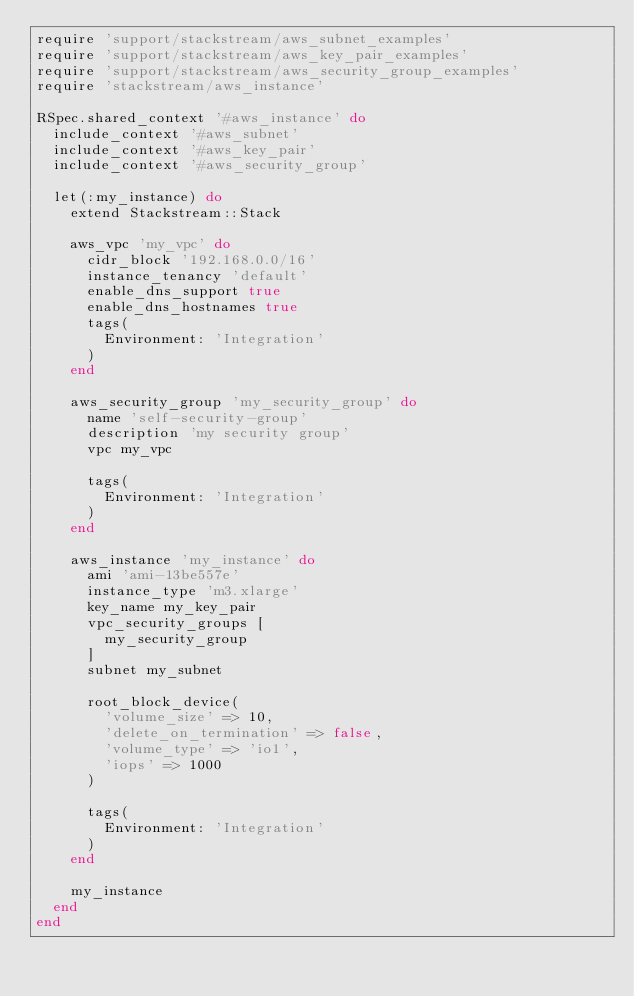Convert code to text. <code><loc_0><loc_0><loc_500><loc_500><_Ruby_>require 'support/stackstream/aws_subnet_examples'
require 'support/stackstream/aws_key_pair_examples'
require 'support/stackstream/aws_security_group_examples'
require 'stackstream/aws_instance'

RSpec.shared_context '#aws_instance' do
  include_context '#aws_subnet'
  include_context '#aws_key_pair'
  include_context '#aws_security_group'

  let(:my_instance) do
    extend Stackstream::Stack

    aws_vpc 'my_vpc' do
      cidr_block '192.168.0.0/16'
      instance_tenancy 'default'
      enable_dns_support true
      enable_dns_hostnames true
      tags(
        Environment: 'Integration'
      )
    end

    aws_security_group 'my_security_group' do
      name 'self-security-group'
      description 'my security group'
      vpc my_vpc

      tags(
        Environment: 'Integration'
      )
    end

    aws_instance 'my_instance' do
      ami 'ami-13be557e'
      instance_type 'm3.xlarge'
      key_name my_key_pair
      vpc_security_groups [
        my_security_group
      ]
      subnet my_subnet

      root_block_device(
        'volume_size' => 10,
        'delete_on_termination' => false,
        'volume_type' => 'io1',
        'iops' => 1000
      )

      tags(
        Environment: 'Integration'
      )
    end

    my_instance
  end
end
</code> 